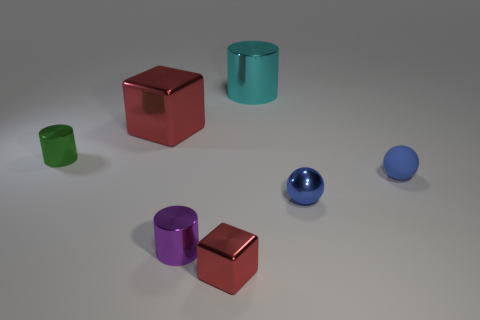Are there any small blocks of the same color as the big shiny cylinder?
Offer a terse response. No. There is a rubber ball that is the same color as the metallic ball; what is its size?
Make the answer very short. Small. Are the small purple object and the tiny cylinder that is behind the blue matte object made of the same material?
Keep it short and to the point. Yes. The thing that is behind the small rubber thing and on the right side of the tiny purple metallic cylinder is made of what material?
Ensure brevity in your answer.  Metal. The metallic cylinder that is on the right side of the purple cylinder in front of the big red object is what color?
Provide a short and direct response. Cyan. There is a large object that is left of the cyan metallic object; what is it made of?
Provide a succinct answer. Metal. Is the number of big brown blocks less than the number of blue shiny balls?
Offer a terse response. Yes. Do the small blue matte thing and the red object that is behind the tiny blue matte object have the same shape?
Offer a terse response. No. There is a shiny thing that is both left of the tiny block and right of the large red block; what is its shape?
Your answer should be very brief. Cylinder. Are there the same number of objects that are behind the blue matte thing and blue metallic things that are on the left side of the large cyan cylinder?
Ensure brevity in your answer.  No. 